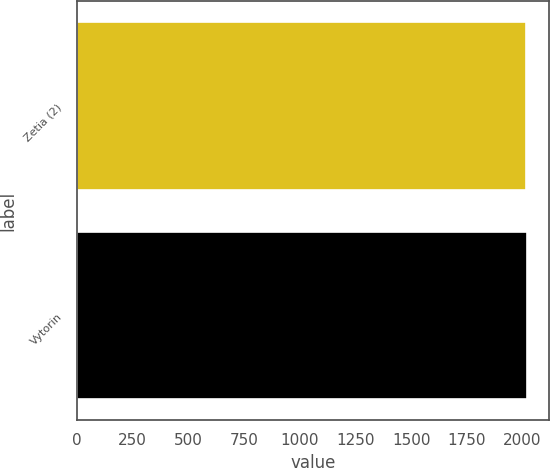<chart> <loc_0><loc_0><loc_500><loc_500><bar_chart><fcel>Zetia (2)<fcel>Vytorin<nl><fcel>2018<fcel>2019<nl></chart> 